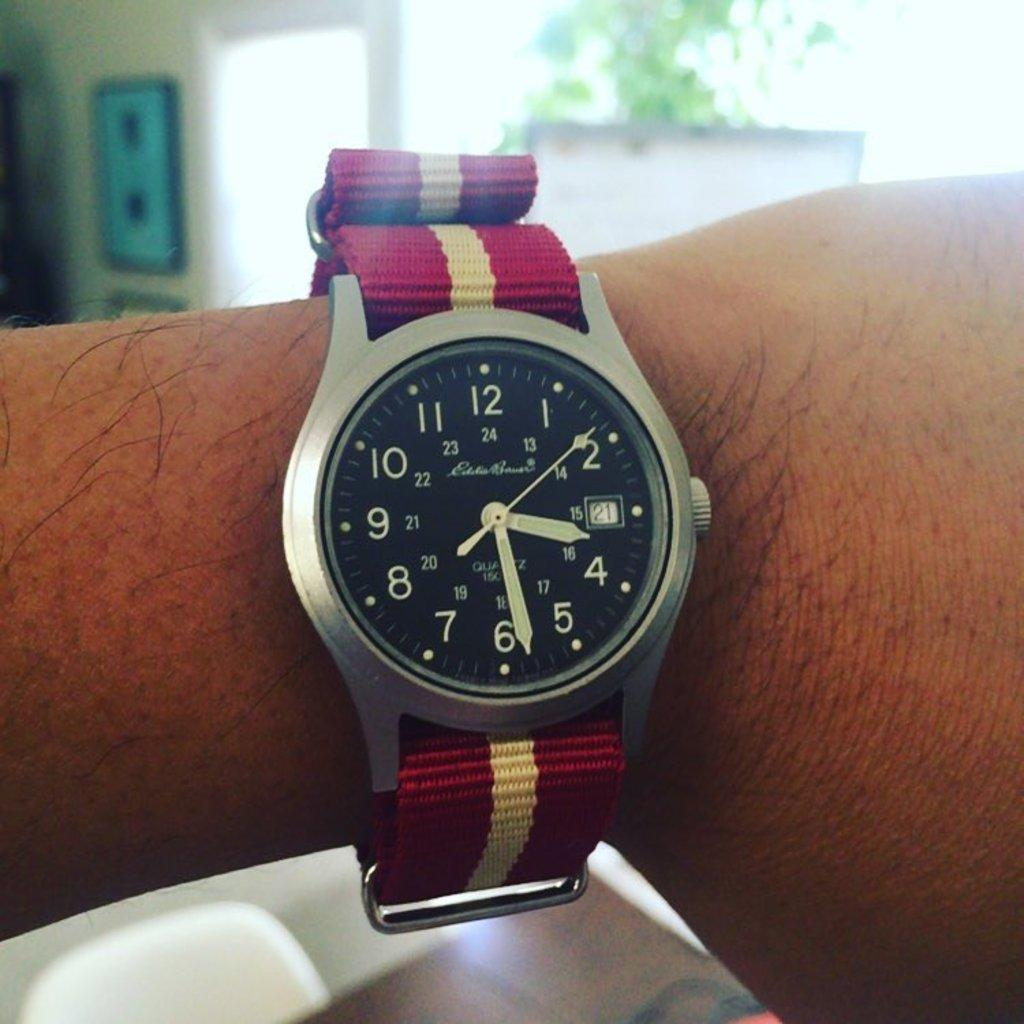<image>
Create a compact narrative representing the image presented. A watch on a man's wrist, the time is set to half past three and the number 21 is visible in a white box. 